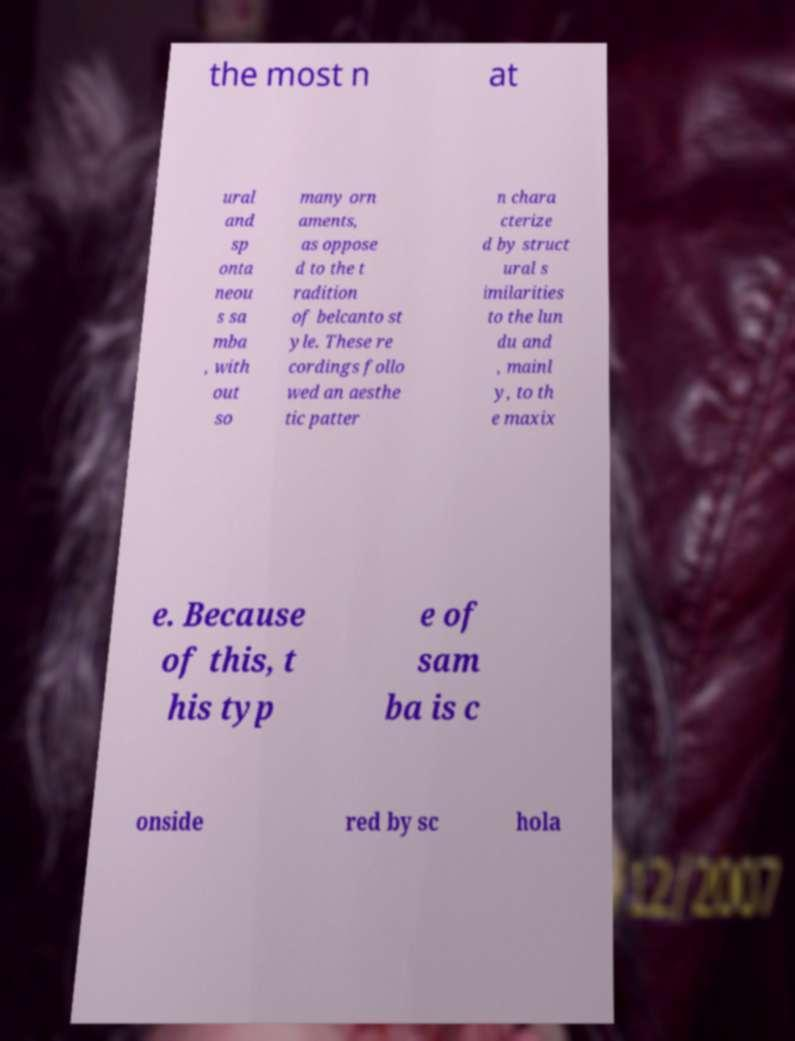There's text embedded in this image that I need extracted. Can you transcribe it verbatim? the most n at ural and sp onta neou s sa mba , with out so many orn aments, as oppose d to the t radition of belcanto st yle. These re cordings follo wed an aesthe tic patter n chara cterize d by struct ural s imilarities to the lun du and , mainl y, to th e maxix e. Because of this, t his typ e of sam ba is c onside red by sc hola 